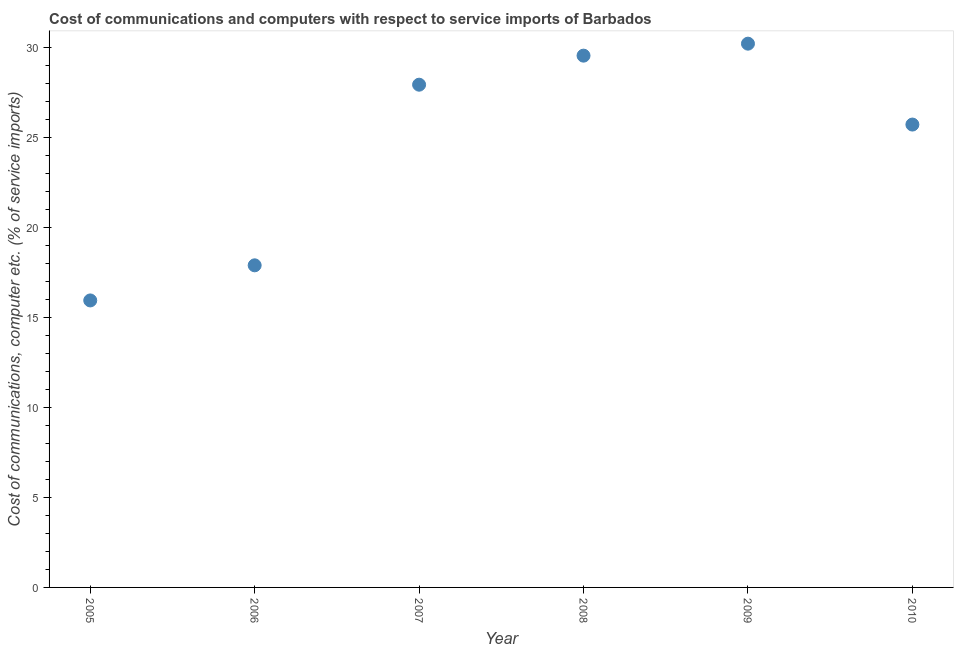What is the cost of communications and computer in 2005?
Make the answer very short. 15.94. Across all years, what is the maximum cost of communications and computer?
Ensure brevity in your answer.  30.21. Across all years, what is the minimum cost of communications and computer?
Give a very brief answer. 15.94. In which year was the cost of communications and computer minimum?
Make the answer very short. 2005. What is the sum of the cost of communications and computer?
Ensure brevity in your answer.  147.23. What is the difference between the cost of communications and computer in 2008 and 2009?
Ensure brevity in your answer.  -0.67. What is the average cost of communications and computer per year?
Make the answer very short. 24.54. What is the median cost of communications and computer?
Ensure brevity in your answer.  26.82. In how many years, is the cost of communications and computer greater than 9 %?
Ensure brevity in your answer.  6. What is the ratio of the cost of communications and computer in 2007 to that in 2009?
Offer a very short reply. 0.92. What is the difference between the highest and the second highest cost of communications and computer?
Make the answer very short. 0.67. What is the difference between the highest and the lowest cost of communications and computer?
Your answer should be compact. 14.26. In how many years, is the cost of communications and computer greater than the average cost of communications and computer taken over all years?
Keep it short and to the point. 4. Does the cost of communications and computer monotonically increase over the years?
Your answer should be very brief. No. How many dotlines are there?
Keep it short and to the point. 1. What is the difference between two consecutive major ticks on the Y-axis?
Provide a short and direct response. 5. Are the values on the major ticks of Y-axis written in scientific E-notation?
Provide a short and direct response. No. Does the graph contain grids?
Your answer should be very brief. No. What is the title of the graph?
Provide a short and direct response. Cost of communications and computers with respect to service imports of Barbados. What is the label or title of the X-axis?
Your response must be concise. Year. What is the label or title of the Y-axis?
Give a very brief answer. Cost of communications, computer etc. (% of service imports). What is the Cost of communications, computer etc. (% of service imports) in 2005?
Offer a terse response. 15.94. What is the Cost of communications, computer etc. (% of service imports) in 2006?
Make the answer very short. 17.89. What is the Cost of communications, computer etc. (% of service imports) in 2007?
Your response must be concise. 27.93. What is the Cost of communications, computer etc. (% of service imports) in 2008?
Provide a short and direct response. 29.54. What is the Cost of communications, computer etc. (% of service imports) in 2009?
Your response must be concise. 30.21. What is the Cost of communications, computer etc. (% of service imports) in 2010?
Offer a terse response. 25.71. What is the difference between the Cost of communications, computer etc. (% of service imports) in 2005 and 2006?
Make the answer very short. -1.95. What is the difference between the Cost of communications, computer etc. (% of service imports) in 2005 and 2007?
Offer a terse response. -11.99. What is the difference between the Cost of communications, computer etc. (% of service imports) in 2005 and 2008?
Make the answer very short. -13.6. What is the difference between the Cost of communications, computer etc. (% of service imports) in 2005 and 2009?
Your answer should be very brief. -14.26. What is the difference between the Cost of communications, computer etc. (% of service imports) in 2005 and 2010?
Keep it short and to the point. -9.77. What is the difference between the Cost of communications, computer etc. (% of service imports) in 2006 and 2007?
Make the answer very short. -10.03. What is the difference between the Cost of communications, computer etc. (% of service imports) in 2006 and 2008?
Offer a very short reply. -11.65. What is the difference between the Cost of communications, computer etc. (% of service imports) in 2006 and 2009?
Make the answer very short. -12.31. What is the difference between the Cost of communications, computer etc. (% of service imports) in 2006 and 2010?
Your answer should be compact. -7.82. What is the difference between the Cost of communications, computer etc. (% of service imports) in 2007 and 2008?
Provide a succinct answer. -1.61. What is the difference between the Cost of communications, computer etc. (% of service imports) in 2007 and 2009?
Ensure brevity in your answer.  -2.28. What is the difference between the Cost of communications, computer etc. (% of service imports) in 2007 and 2010?
Give a very brief answer. 2.21. What is the difference between the Cost of communications, computer etc. (% of service imports) in 2008 and 2009?
Your response must be concise. -0.67. What is the difference between the Cost of communications, computer etc. (% of service imports) in 2008 and 2010?
Offer a very short reply. 3.83. What is the difference between the Cost of communications, computer etc. (% of service imports) in 2009 and 2010?
Your response must be concise. 4.49. What is the ratio of the Cost of communications, computer etc. (% of service imports) in 2005 to that in 2006?
Provide a succinct answer. 0.89. What is the ratio of the Cost of communications, computer etc. (% of service imports) in 2005 to that in 2007?
Your response must be concise. 0.57. What is the ratio of the Cost of communications, computer etc. (% of service imports) in 2005 to that in 2008?
Provide a short and direct response. 0.54. What is the ratio of the Cost of communications, computer etc. (% of service imports) in 2005 to that in 2009?
Ensure brevity in your answer.  0.53. What is the ratio of the Cost of communications, computer etc. (% of service imports) in 2005 to that in 2010?
Your answer should be compact. 0.62. What is the ratio of the Cost of communications, computer etc. (% of service imports) in 2006 to that in 2007?
Give a very brief answer. 0.64. What is the ratio of the Cost of communications, computer etc. (% of service imports) in 2006 to that in 2008?
Your answer should be compact. 0.61. What is the ratio of the Cost of communications, computer etc. (% of service imports) in 2006 to that in 2009?
Your response must be concise. 0.59. What is the ratio of the Cost of communications, computer etc. (% of service imports) in 2006 to that in 2010?
Ensure brevity in your answer.  0.7. What is the ratio of the Cost of communications, computer etc. (% of service imports) in 2007 to that in 2008?
Make the answer very short. 0.94. What is the ratio of the Cost of communications, computer etc. (% of service imports) in 2007 to that in 2009?
Make the answer very short. 0.93. What is the ratio of the Cost of communications, computer etc. (% of service imports) in 2007 to that in 2010?
Your answer should be compact. 1.09. What is the ratio of the Cost of communications, computer etc. (% of service imports) in 2008 to that in 2010?
Offer a very short reply. 1.15. What is the ratio of the Cost of communications, computer etc. (% of service imports) in 2009 to that in 2010?
Offer a very short reply. 1.18. 